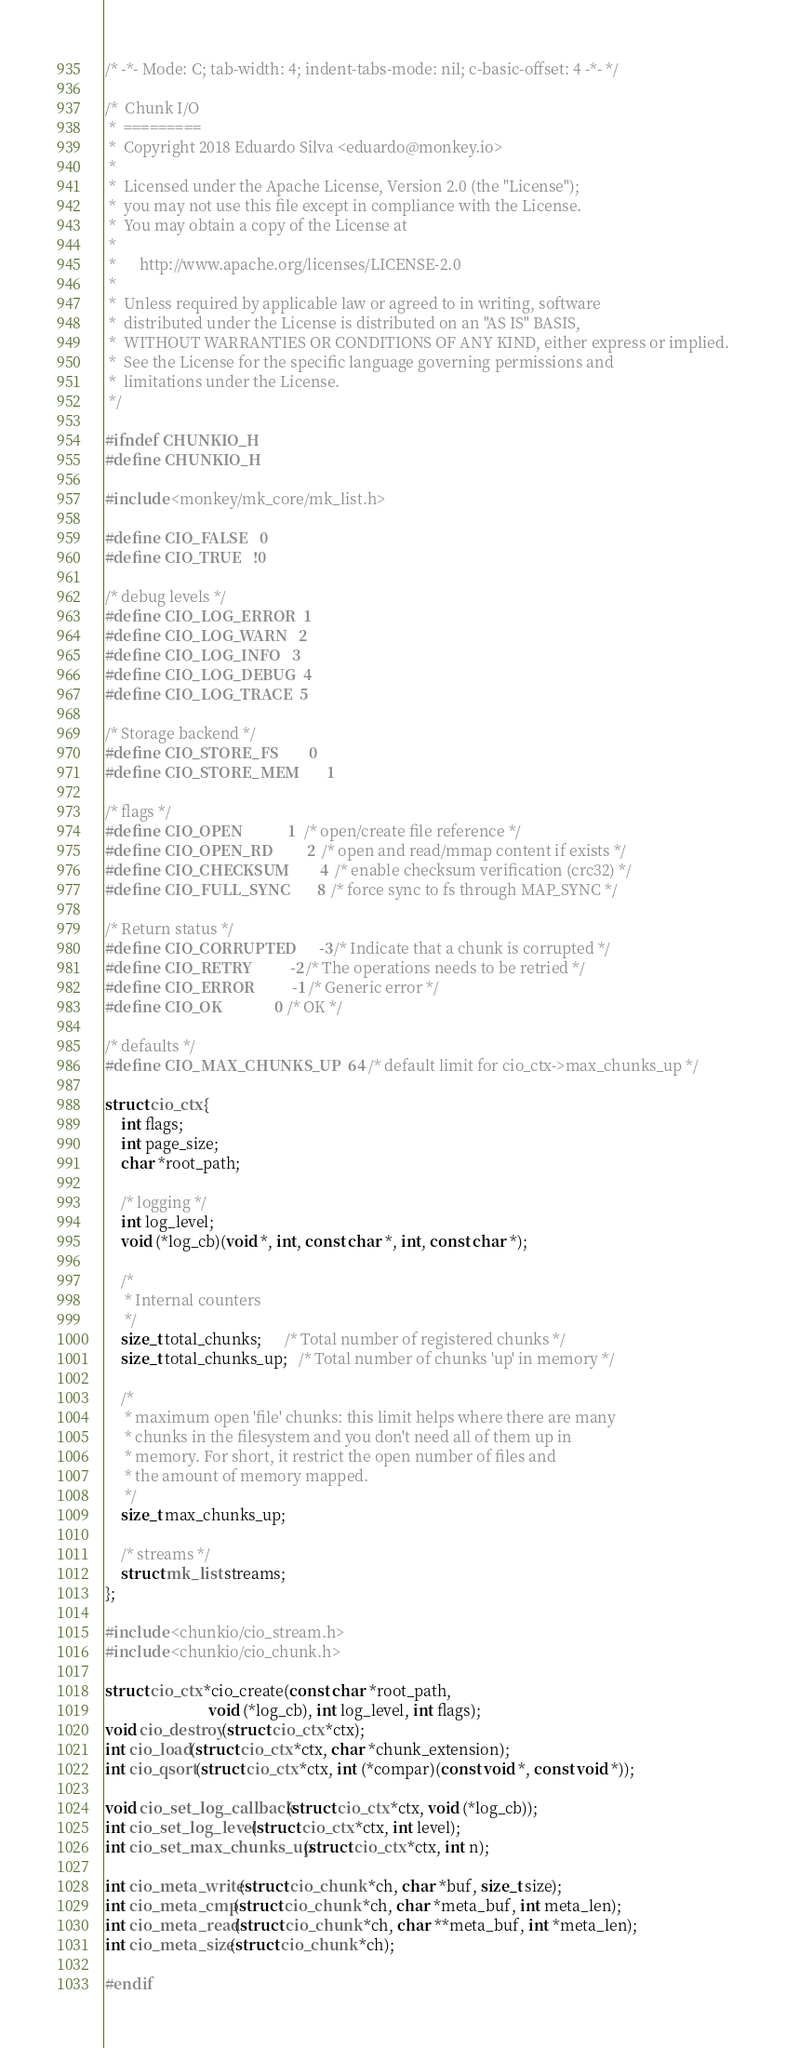Convert code to text. <code><loc_0><loc_0><loc_500><loc_500><_C_>/* -*- Mode: C; tab-width: 4; indent-tabs-mode: nil; c-basic-offset: 4 -*- */

/*  Chunk I/O
 *  =========
 *  Copyright 2018 Eduardo Silva <eduardo@monkey.io>
 *
 *  Licensed under the Apache License, Version 2.0 (the "License");
 *  you may not use this file except in compliance with the License.
 *  You may obtain a copy of the License at
 *
 *      http://www.apache.org/licenses/LICENSE-2.0
 *
 *  Unless required by applicable law or agreed to in writing, software
 *  distributed under the License is distributed on an "AS IS" BASIS,
 *  WITHOUT WARRANTIES OR CONDITIONS OF ANY KIND, either express or implied.
 *  See the License for the specific language governing permissions and
 *  limitations under the License.
 */

#ifndef CHUNKIO_H
#define CHUNKIO_H

#include <monkey/mk_core/mk_list.h>

#define CIO_FALSE   0
#define CIO_TRUE   !0

/* debug levels */
#define CIO_LOG_ERROR  1
#define CIO_LOG_WARN   2
#define CIO_LOG_INFO   3
#define CIO_LOG_DEBUG  4
#define CIO_LOG_TRACE  5

/* Storage backend */
#define CIO_STORE_FS        0
#define CIO_STORE_MEM       1

/* flags */
#define CIO_OPEN            1   /* open/create file reference */
#define CIO_OPEN_RD         2   /* open and read/mmap content if exists */
#define CIO_CHECKSUM        4   /* enable checksum verification (crc32) */
#define CIO_FULL_SYNC       8   /* force sync to fs through MAP_SYNC */

/* Return status */
#define CIO_CORRUPTED      -3  /* Indicate that a chunk is corrupted */
#define CIO_RETRY          -2  /* The operations needs to be retried */
#define CIO_ERROR          -1  /* Generic error */
#define CIO_OK              0  /* OK */

/* defaults */
#define CIO_MAX_CHUNKS_UP  64   /* default limit for cio_ctx->max_chunks_up */

struct cio_ctx {
    int flags;
    int page_size;
    char *root_path;

    /* logging */
    int log_level;
    void (*log_cb)(void *, int, const char *, int, const char *);

    /*
     * Internal counters
     */
    size_t total_chunks;      /* Total number of registered chunks */
    size_t total_chunks_up;   /* Total number of chunks 'up' in memory */

    /*
     * maximum open 'file' chunks: this limit helps where there are many
     * chunks in the filesystem and you don't need all of them up in
     * memory. For short, it restrict the open number of files and
     * the amount of memory mapped.
     */
    size_t max_chunks_up;

    /* streams */
    struct mk_list streams;
};

#include <chunkio/cio_stream.h>
#include <chunkio/cio_chunk.h>

struct cio_ctx *cio_create(const char *root_path,
                           void (*log_cb), int log_level, int flags);
void cio_destroy(struct cio_ctx *ctx);
int cio_load(struct cio_ctx *ctx, char *chunk_extension);
int cio_qsort(struct cio_ctx *ctx, int (*compar)(const void *, const void *));

void cio_set_log_callback(struct cio_ctx *ctx, void (*log_cb));
int cio_set_log_level(struct cio_ctx *ctx, int level);
int cio_set_max_chunks_up(struct cio_ctx *ctx, int n);

int cio_meta_write(struct cio_chunk *ch, char *buf, size_t size);
int cio_meta_cmp(struct cio_chunk *ch, char *meta_buf, int meta_len);
int cio_meta_read(struct cio_chunk *ch, char **meta_buf, int *meta_len);
int cio_meta_size(struct cio_chunk *ch);

#endif
</code> 